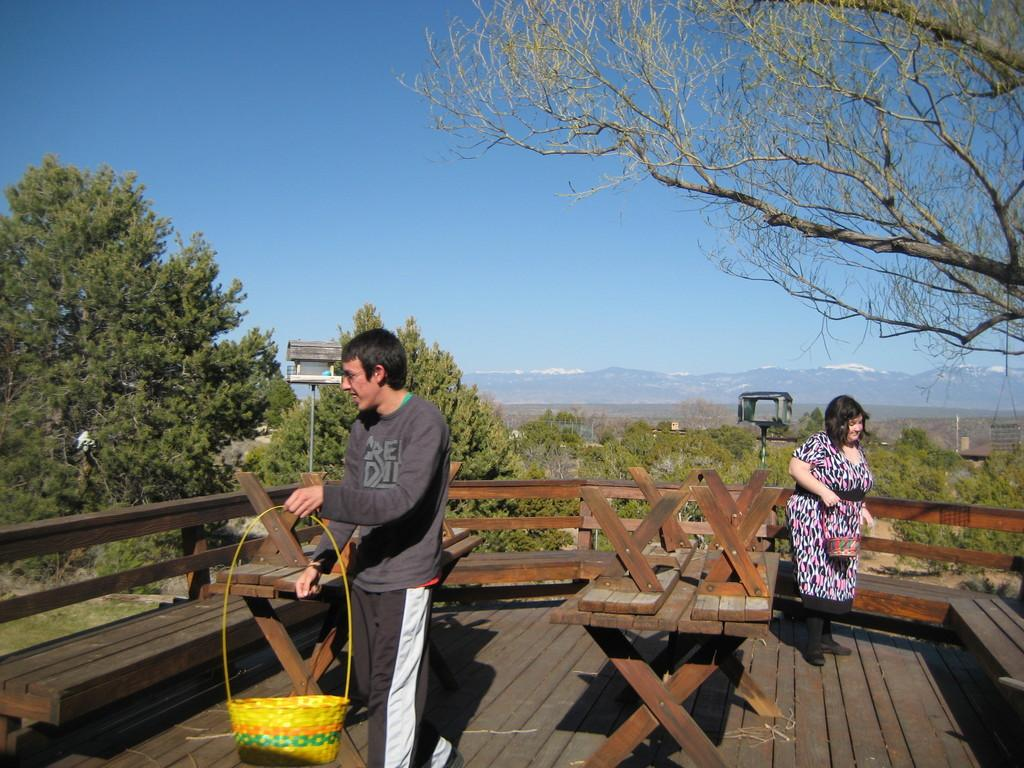How many people are in the image? There are two persons standing in the image. What are the persons holding in the image? The persons are holding a basket. What piece of furniture is present in the image? There is a bench in the image. What part of the environment is visible under the persons' feet? The floor is visible in the image. What type of natural scenery can be seen in the background of the image? There are trees in the background of the image. What part of the sky is visible in the background of the image? The sky is visible in the background of the image. What type of yak can be seen wearing a glove in the image? There is no yak or glove present in the image. What type of coach is visible in the background of the image? There is no coach present in the image. 